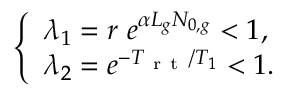<formula> <loc_0><loc_0><loc_500><loc_500>\left \{ \begin{array} { l l } { \lambda _ { 1 } = r \ e ^ { \alpha L _ { g } N _ { 0 , g } } < 1 , } \\ { \lambda _ { 2 } = e ^ { - T _ { r t } / T _ { 1 } } < 1 . } \end{array}</formula> 